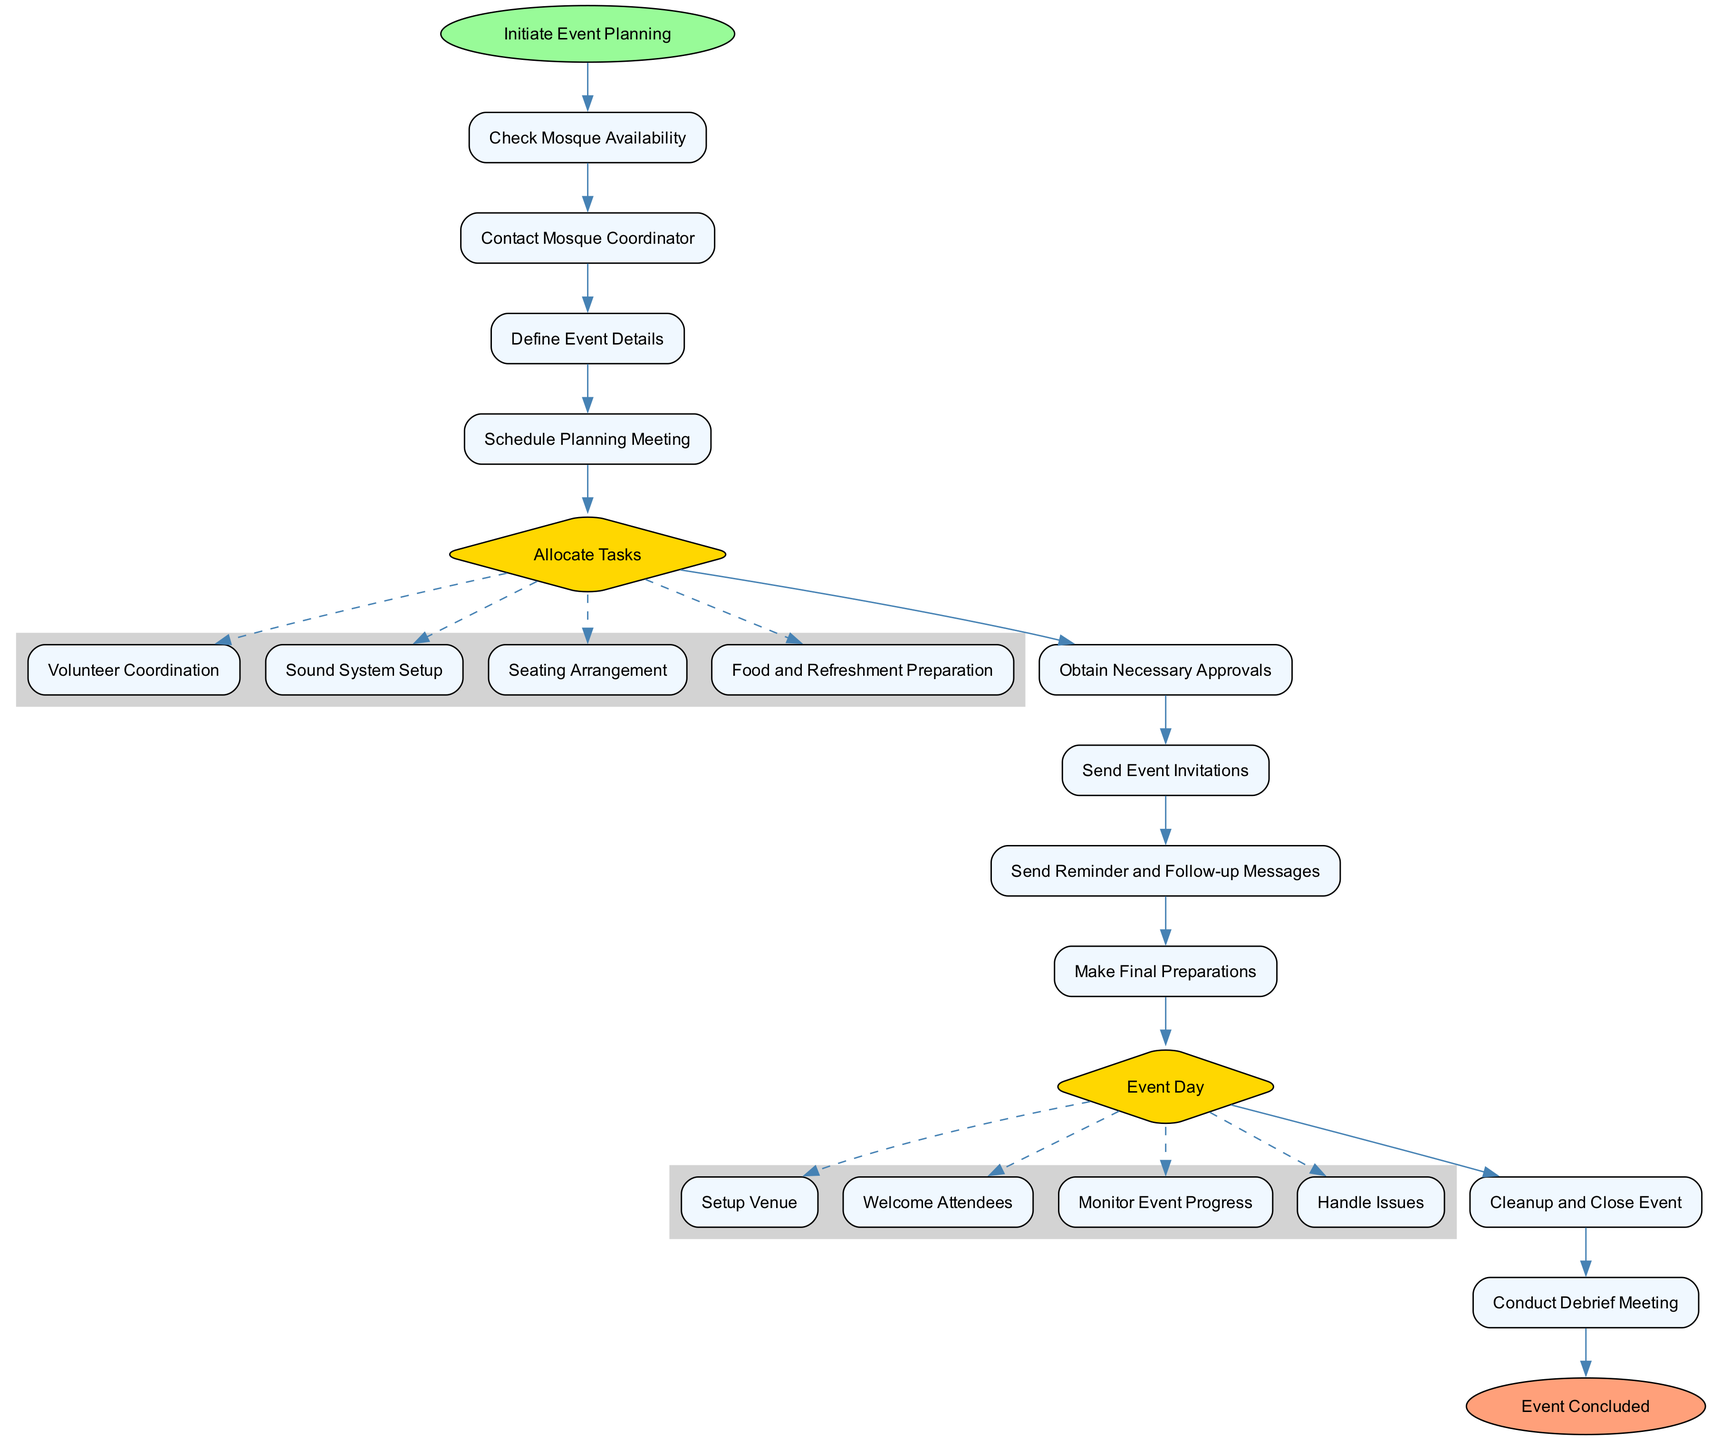What is the first step in the event planning process? The diagram indicates the first step in the flowchart is "Initiate Event Planning," which is labeled as the starting node and is represented at the top of the diagram.
Answer: Initiate Event Planning How many tasks are there under "Allocate Tasks"? Under the "Allocate Tasks" node, there are four specific sub-tasks listed: "Volunteer Coordination," "Sound System Setup," "Seating Arrangement," and "Food and Refreshment Preparation." This indicates that there are four tasks allocated in total.
Answer: Four What is the final step before the event concludes? The final step before the end event is indicated as "Conduct Debrief Meeting," which directly precedes "Event Concluded" in the flow of the diagram.
Answer: Conduct Debrief Meeting What follows "Send Event Invitations"? After "Send Event Invitations," the next step in the flow is "Send Reminder and Follow-up Messages," indicating this is the sequence for communication with attendees post-invitation.
Answer: Send Reminder and Follow-up Messages How many subtasks are in the "Event Day" section? The "Event Day" section consists of four subtasks: "Setup Venue," "Welcome Attendees," "Monitor Event Progress," and "Handle Issues," indicating that a total of four distinct activities take place during the event day.
Answer: Four What is the purpose of the "Check Mosque Availability" step? The step "Check Mosque Availability" serves to ensure that the mosque can host the event, indicating that verifying the venue's availability is crucial before proceeding with other planning tasks.
Answer: To ensure availability How many edges connect directly to the "Allocate Tasks" node? The "Allocate Tasks" node is connected directly by one edge from the previous step and has four dashed edges leading to its sub-tasks, resulting in a total of five connecting edges.
Answer: Five Which node represents the stage of final preparations? The stage of final preparations is represented by the node "Make Final Preparations," which directly follows the reminder step and comes before the event day starts.
Answer: Make Final Preparations What action is taken on the event day? On the event day, a series of actions such as "Setup Venue," "Welcome Attendees," "Monitor Event Progress," and "Handle Issues" are undertaken, all pertaining to the successful execution of the event.
Answer: Setup Venue, Welcome Attendees, Monitor Event Progress, Handle Issues 